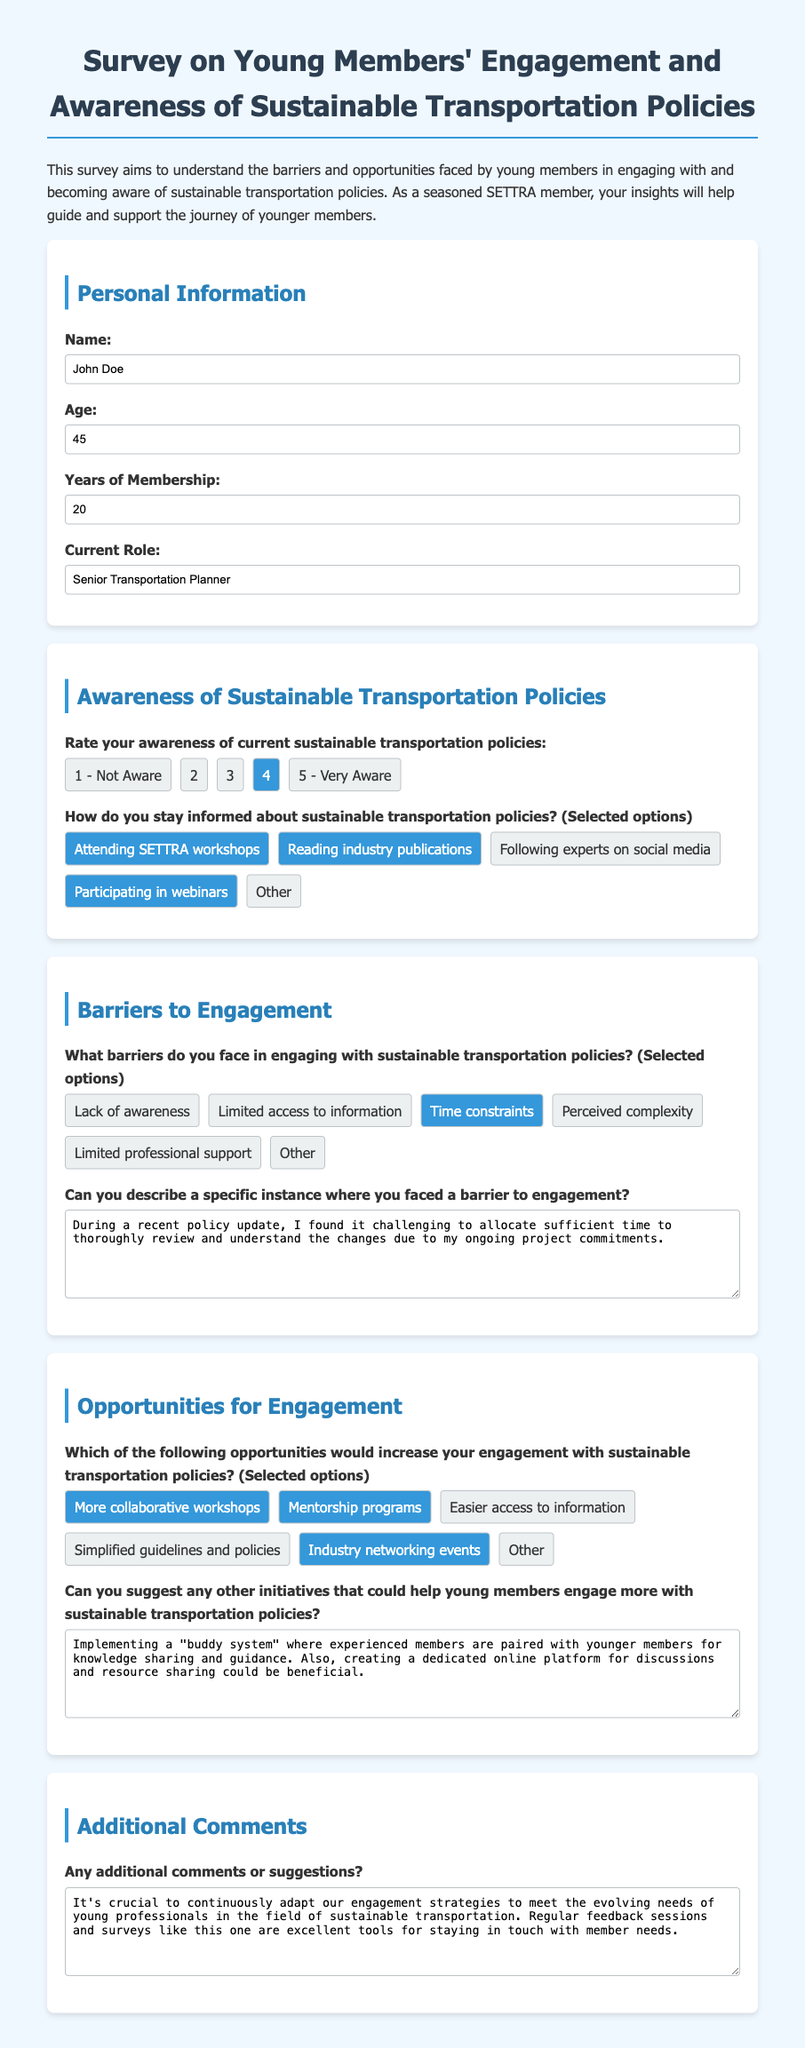What is the name of the respondent? The name of the respondent is found in the Personal Information section of the document.
Answer: John Doe How old is the respondent? The age of the respondent is stated in the Personal Information section of the document.
Answer: 45 How many years of membership does the respondent have? The number of years of membership is in the Personal Information section of the document.
Answer: 20 What is the respondent's current role? The current role of the respondent is listed in the Personal Information section of the document.
Answer: Senior Transportation Planner What is the respondent's awareness rating of current sustainable transportation policies? The awareness rating is located in the Awareness of Sustainable Transportation Policies section of the document.
Answer: 4 What barriers does the respondent face in engaging with sustainable transportation policies? The barriers faced by the respondent are listed in the Barriers to Engagement section of the document.
Answer: Time constraints What opportunities would increase the respondent's engagement with sustainable transportation policies? The opportunities for increasing engagement are mentioned in the Opportunities for Engagement section of the document.
Answer: More collaborative workshops What specific instance of a barrier to engagement did the respondent describe? The specific instance is detailed in the Barriers to Engagement section of the document.
Answer: Recent policy update challenges What initiative does the respondent suggest for young members? The initiative suggested by the respondent can be found in the Opportunities for Engagement section.
Answer: Implementing a "buddy system" What additional comments does the respondent have? The additional comments are stated in the Additional Comments section of the document.
Answer: It's crucial to continuously adapt our engagement strategies 